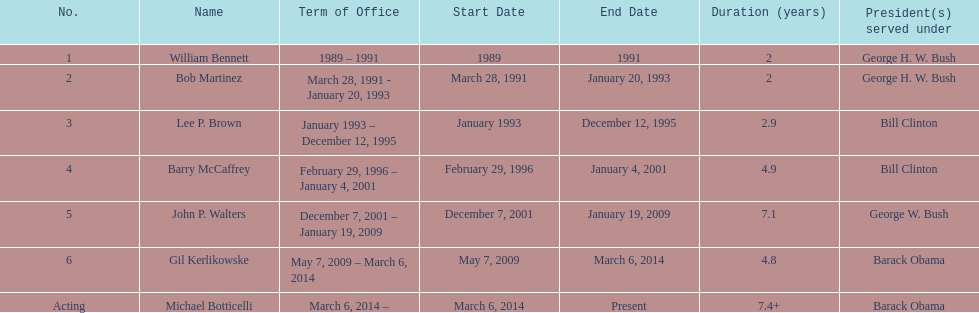How long did the first director serve in office? 2 years. 